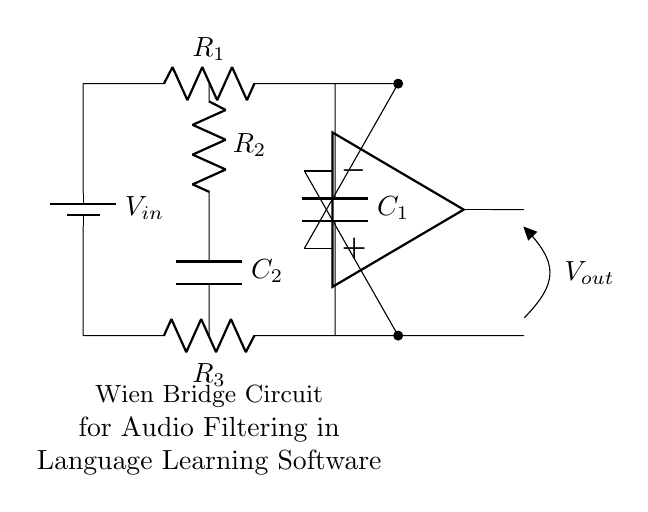What is the function of R1 in this circuit? R1 is part of the Wien bridge and helps determine the frequency response alongside the other resistors and capacitors in the circuit.
Answer: Resistance What is the total number of resistors in the circuit? There are four resistors present, R1, R2, and R3, with R2 functioning in the feedback loop of the op-amp.
Answer: Four What is the purpose of the capacitor C2? C2 is used to set the frequency characteristics of the Wien bridge, working with R2 to filter specific frequencies in the audio signal.
Answer: Filtering What type of circuit is represented? This circuit is a Wien bridge circuit, which is typically used for frequency filtering in audio applications.
Answer: Wien bridge Which component provides the output voltage? The output voltage is provided by the operational amplifier, which amplifies the input signal processed through the circuit.
Answer: Op-amp How does the circuit determine frequency response? The frequency response is determined by the values of the resistors and capacitors (R1, R2, C1, C2) in the Wien bridge arrangement, setting the cut-off frequencies for filtering.
Answer: Resistor and Capacitor values What connects the two capacitors in this circuit? The two capacitors C1 and C2 are connected in series with different resistance values, affecting the overall impedance and frequency filtering characteristics of the circuit.
Answer: Short connections 